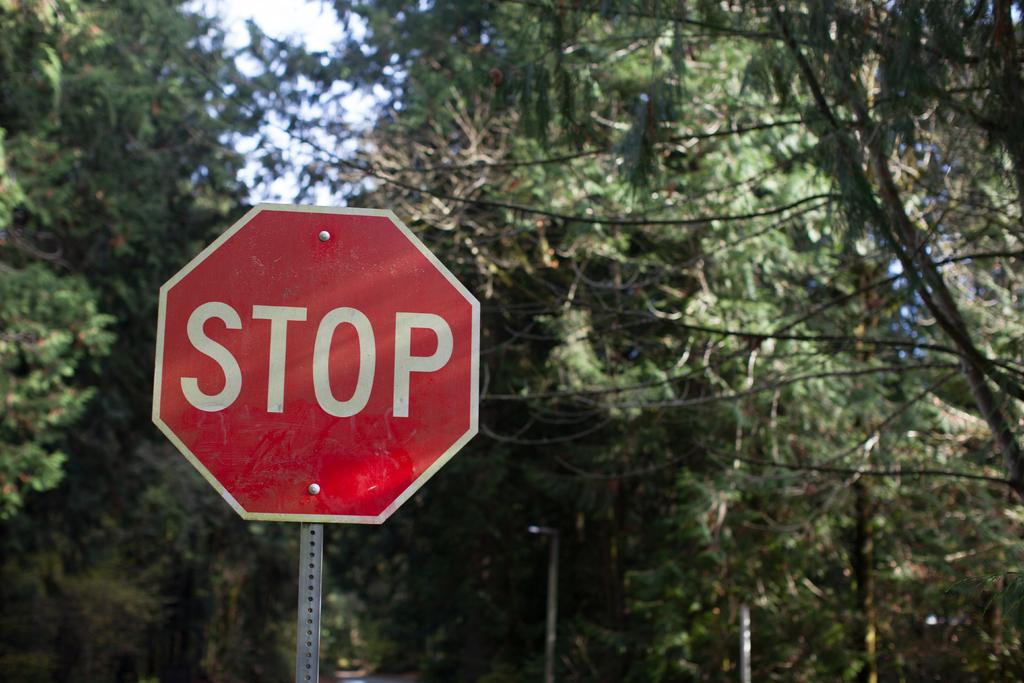<image>
Present a compact description of the photo's key features. a stop sign that is outside among the trees 